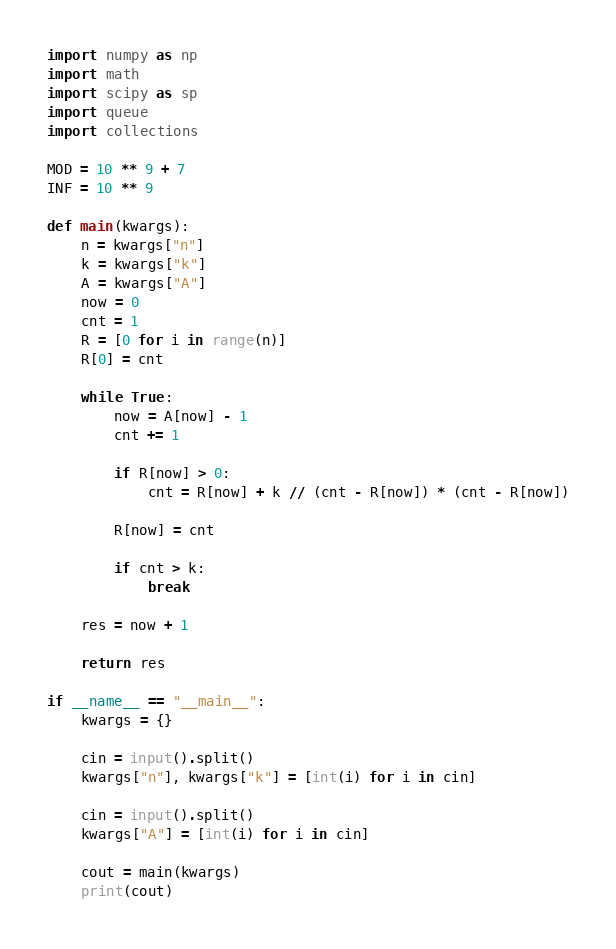Convert code to text. <code><loc_0><loc_0><loc_500><loc_500><_Python_>import numpy as np
import math
import scipy as sp
import queue
import collections

MOD = 10 ** 9 + 7
INF = 10 ** 9

def main(kwargs):
    n = kwargs["n"]
    k = kwargs["k"]
    A = kwargs["A"]
    now = 0
    cnt = 1
    R = [0 for i in range(n)]
    R[0] = cnt

    while True:
        now = A[now] - 1
        cnt += 1

        if R[now] > 0:
            cnt = R[now] + k // (cnt - R[now]) * (cnt - R[now])

        R[now] = cnt

        if cnt > k:
            break

    res = now + 1

    return res

if __name__ == "__main__":
    kwargs = {}

    cin = input().split()
    kwargs["n"], kwargs["k"] = [int(i) for i in cin]

    cin = input().split()
    kwargs["A"] = [int(i) for i in cin]

    cout = main(kwargs)
    print(cout)</code> 